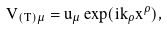<formula> <loc_0><loc_0><loc_500><loc_500>V _ { ( T ) \mu } = u _ { \mu } \exp ( i k _ { \rho } x ^ { \rho } ) ,</formula> 